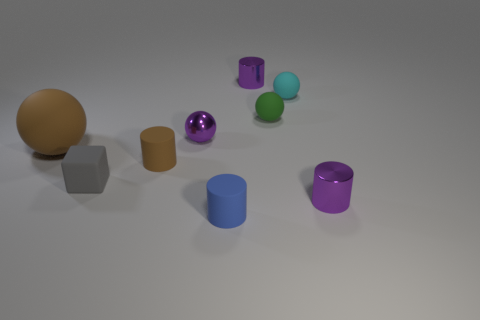Subtract all blue cylinders. How many cylinders are left? 3 Subtract all purple cylinders. How many cylinders are left? 2 Subtract all cubes. How many objects are left? 8 Add 3 brown blocks. How many brown blocks exist? 3 Add 1 tiny metallic cylinders. How many objects exist? 10 Subtract 2 purple cylinders. How many objects are left? 7 Subtract 1 blocks. How many blocks are left? 0 Subtract all brown spheres. Subtract all red blocks. How many spheres are left? 3 Subtract all brown spheres. How many cyan blocks are left? 0 Subtract all small purple cylinders. Subtract all purple shiny objects. How many objects are left? 4 